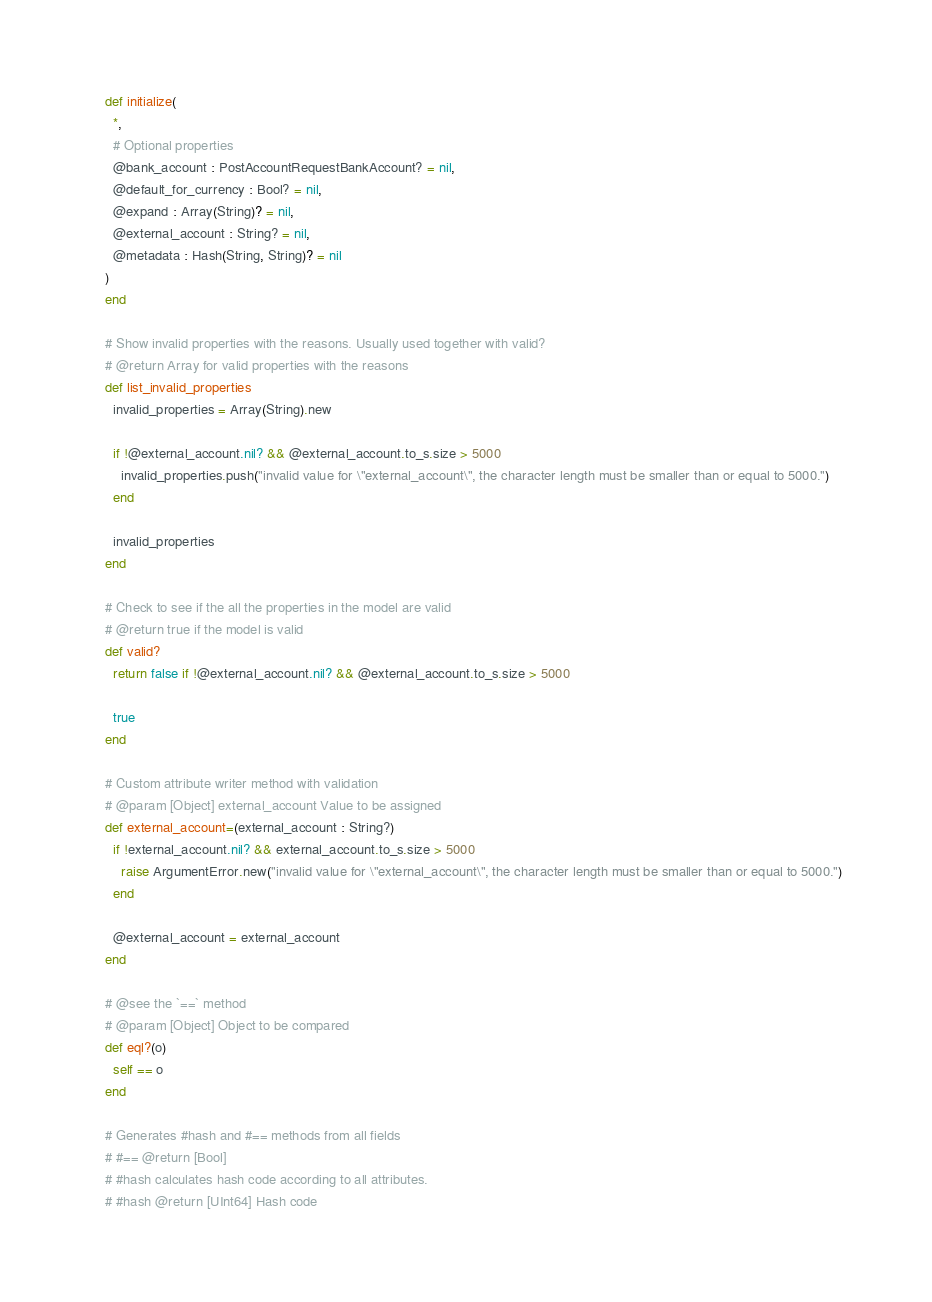Convert code to text. <code><loc_0><loc_0><loc_500><loc_500><_Crystal_>    def initialize(
      *,
      # Optional properties
      @bank_account : PostAccountRequestBankAccount? = nil,
      @default_for_currency : Bool? = nil,
      @expand : Array(String)? = nil,
      @external_account : String? = nil,
      @metadata : Hash(String, String)? = nil
    )
    end

    # Show invalid properties with the reasons. Usually used together with valid?
    # @return Array for valid properties with the reasons
    def list_invalid_properties
      invalid_properties = Array(String).new

      if !@external_account.nil? && @external_account.to_s.size > 5000
        invalid_properties.push("invalid value for \"external_account\", the character length must be smaller than or equal to 5000.")
      end

      invalid_properties
    end

    # Check to see if the all the properties in the model are valid
    # @return true if the model is valid
    def valid?
      return false if !@external_account.nil? && @external_account.to_s.size > 5000

      true
    end

    # Custom attribute writer method with validation
    # @param [Object] external_account Value to be assigned
    def external_account=(external_account : String?)
      if !external_account.nil? && external_account.to_s.size > 5000
        raise ArgumentError.new("invalid value for \"external_account\", the character length must be smaller than or equal to 5000.")
      end

      @external_account = external_account
    end

    # @see the `==` method
    # @param [Object] Object to be compared
    def eql?(o)
      self == o
    end

    # Generates #hash and #== methods from all fields
    # #== @return [Bool]
    # #hash calculates hash code according to all attributes.
    # #hash @return [UInt64] Hash code</code> 